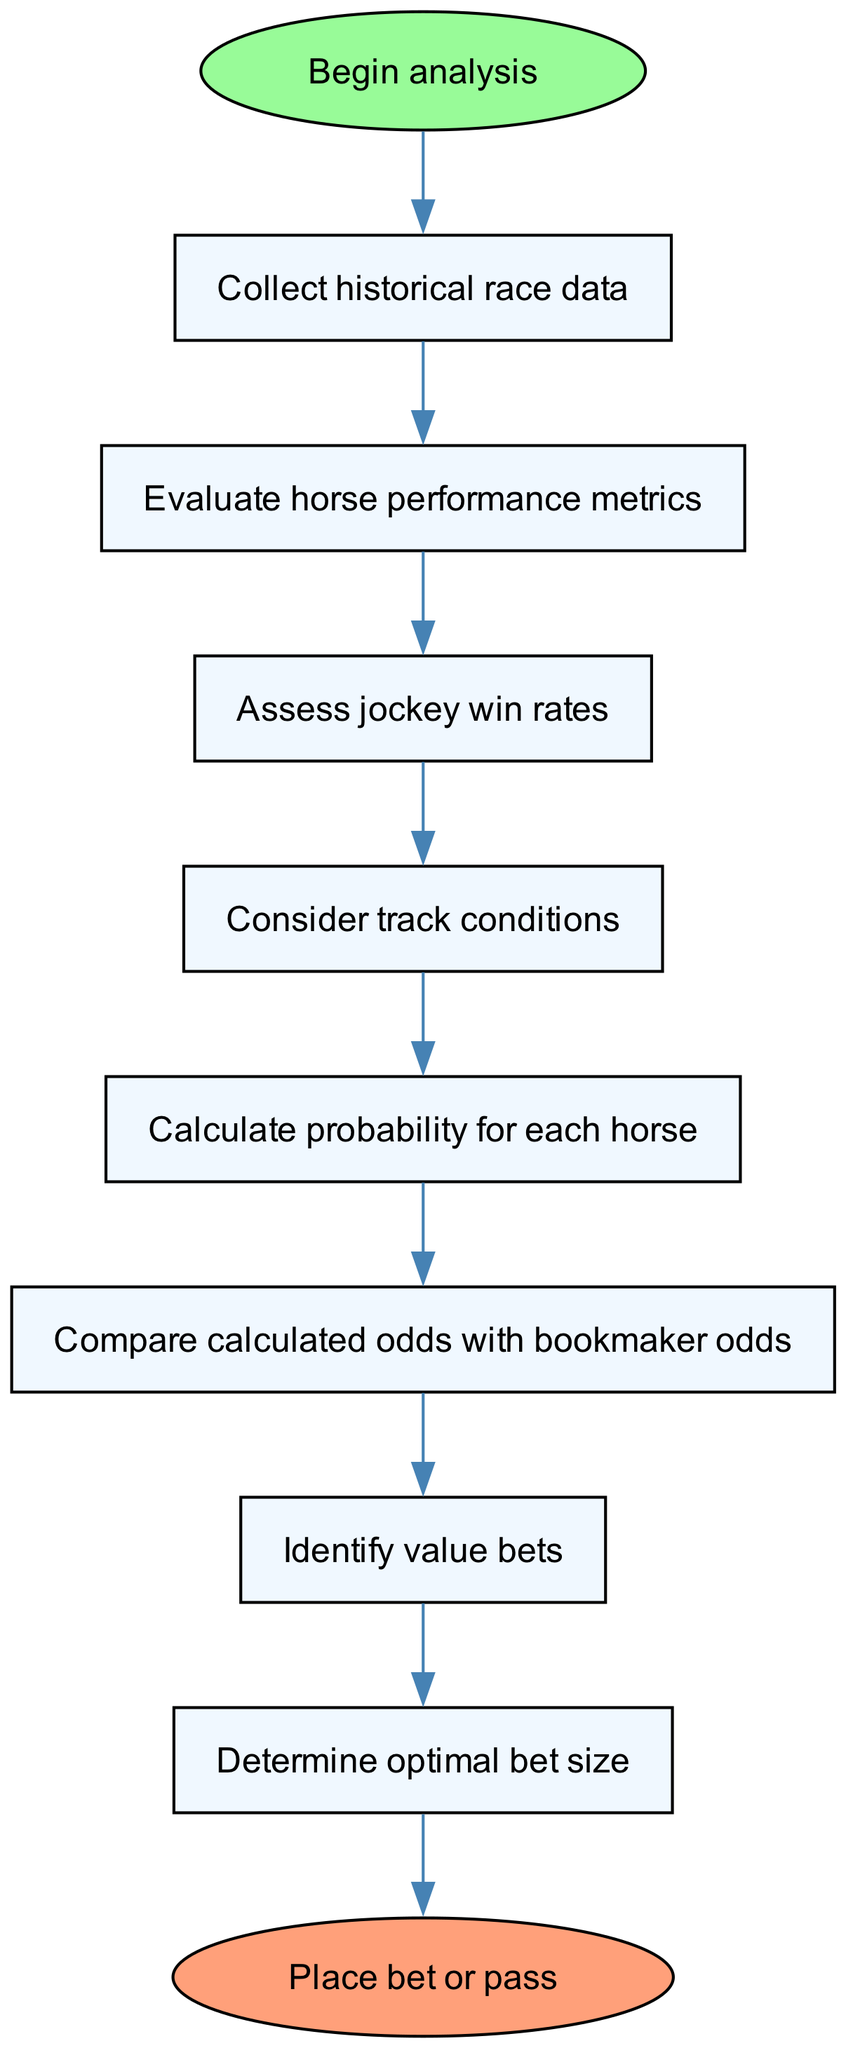What is the first step in the analysis? The diagram starts with the node labeled "Collect historical race data," which indicates the initial action in the process.
Answer: Collect historical race data How many nodes are present in the diagram? By counting the individual steps and the start and end nodes in the diagram, there are a total of 8 nodes plus 2 for start and end, equating to 10 nodes.
Answer: 10 What is the last step before placing a bet? The penultimate action before the final decision to "Place bet or pass" is "Determine optimal bet size," which represents the final preparation step in the betting process.
Answer: Determine optimal bet size What factors are considered before calculating the probability for each horse? The diagram shows that "Assess jockey win rates" and "Consider track conditions" are both evaluated as factors before the calculation of each horse's probability.
Answer: Assess jockey win rates and Consider track conditions Which components lead to identifying value bets? The flowchart illustrates that after calculating the probability for each horse and comparing those odds with bookmaker odds, the next logical step is to identify value bets.
Answer: Calculate probability for each horse and Compare calculated odds with bookmaker odds What action follows after evaluating horse performance metrics? According to the diagram, after the evaluation of horse performance metrics, the next action specified is "Assess jockey win rates."
Answer: Assess jockey win rates How do you determine whether to place a bet? The decision to place a bet or pass is based on the preceding steps, with "Determine optimal bet size" leading directly to the final choice of action in the analysis flow.
Answer: Place bet or pass What is the relationship between node "Compare calculated odds with bookmaker odds" and "Identify value bets"? The process indicates that comparing calculated odds with bookmaker odds is a prerequisite for identifying value bets, highlighting a sequential dependency.
Answer: Sequential dependency 